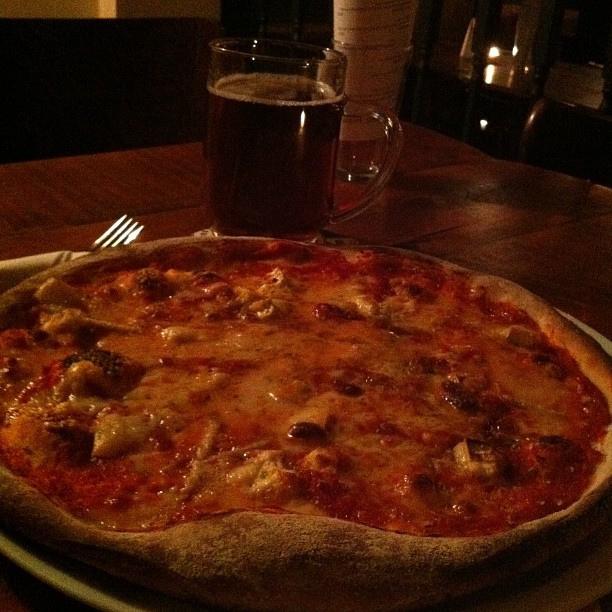What utensil is sitting next to the food?
Short answer required. Fork. What is in the jug?
Short answer required. Beer. What is the name of this crusted food?
Answer briefly. Pizza. 